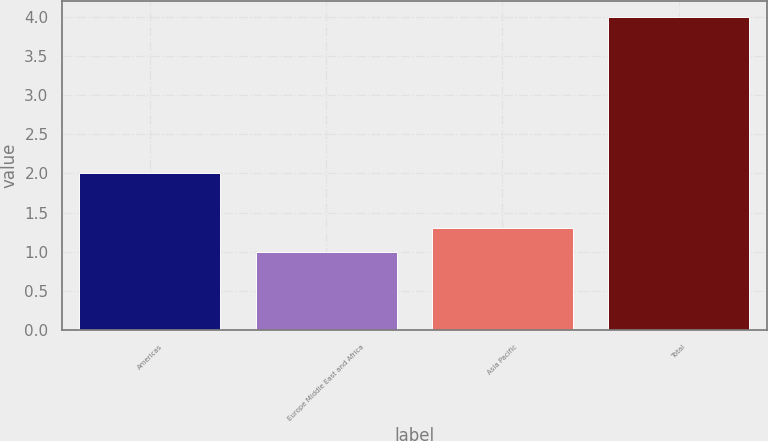Convert chart. <chart><loc_0><loc_0><loc_500><loc_500><bar_chart><fcel>Americas<fcel>Europe Middle East and Africa<fcel>Asia Pacific<fcel>Total<nl><fcel>2<fcel>1<fcel>1.3<fcel>4<nl></chart> 